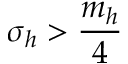<formula> <loc_0><loc_0><loc_500><loc_500>\sigma _ { h } > \frac { m _ { h } } { 4 }</formula> 